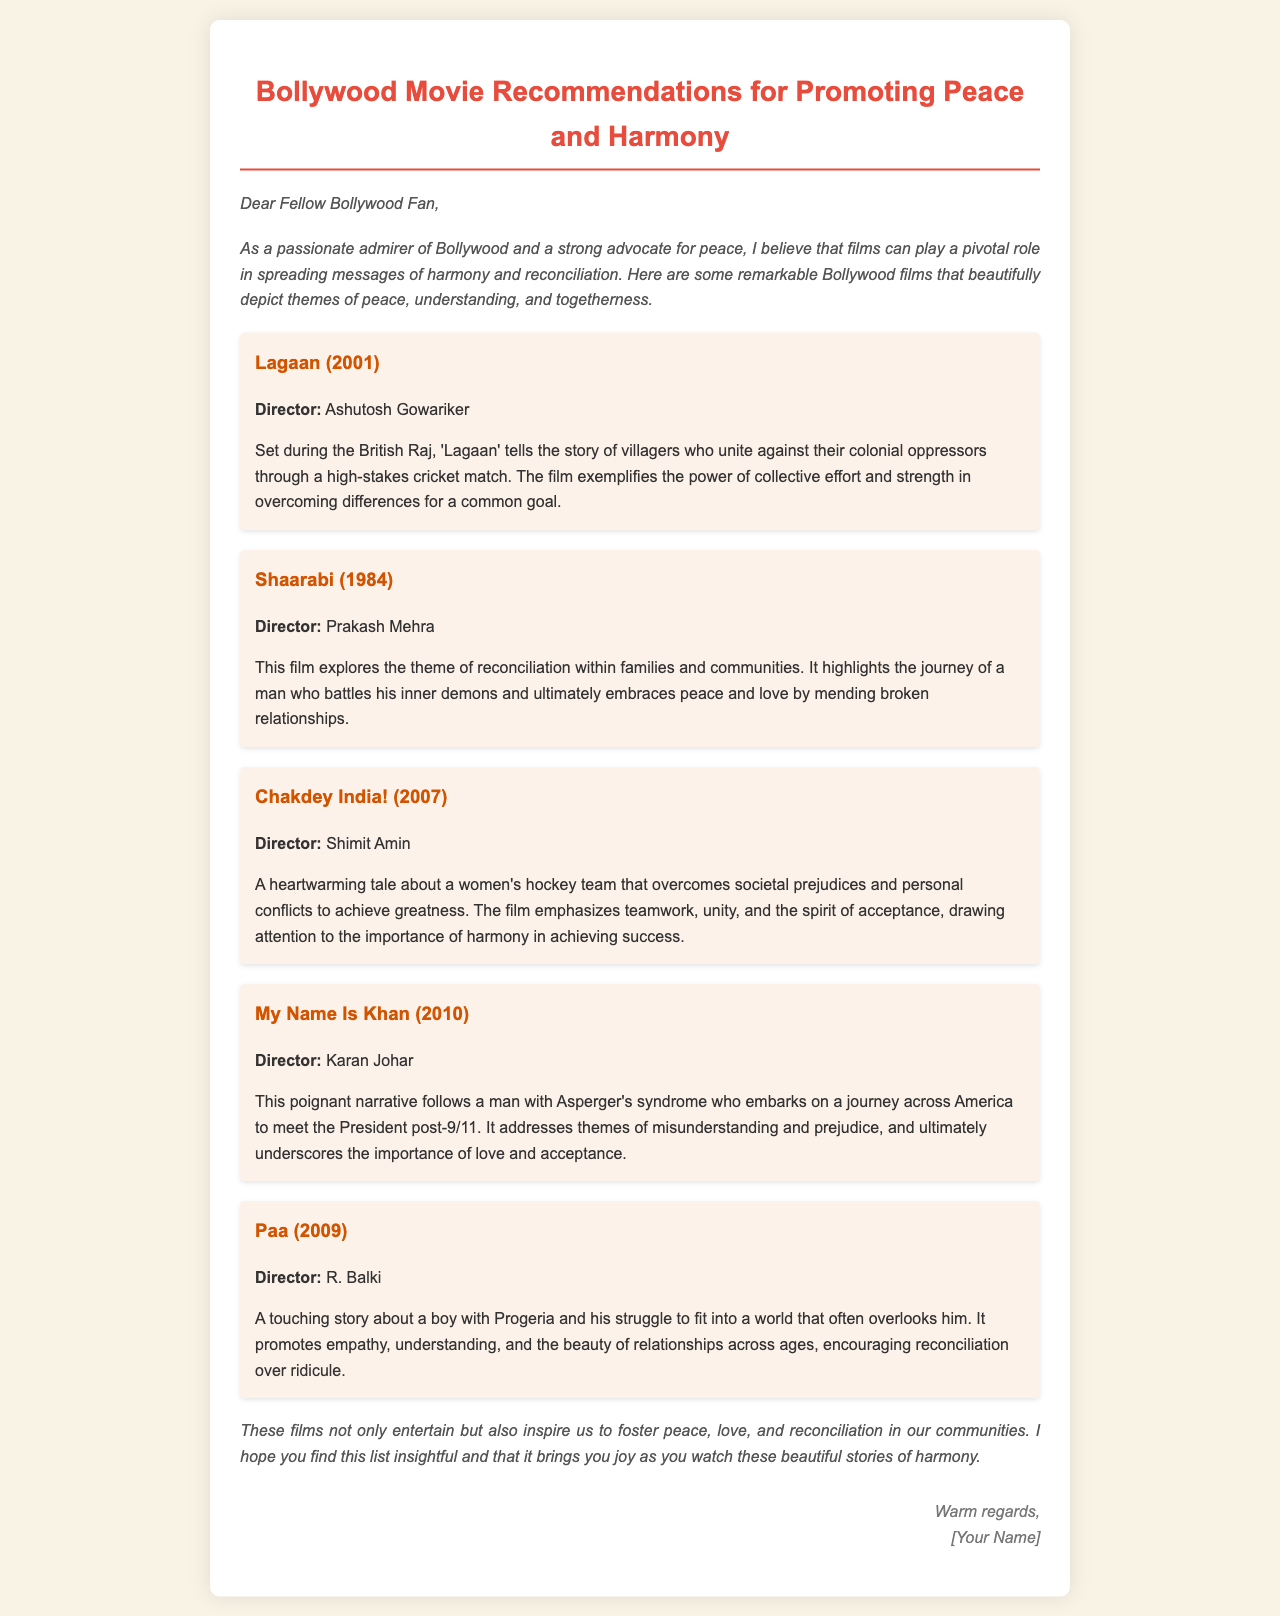What is the title of the email? The title of the email is the first heading presented, which introduces the topic of the email.
Answer: Bollywood Movie Recommendations for Promoting Peace and Harmony Who directed Lagaan? The document specifies the director of Lagaan in the overview of the film.
Answer: Ashutosh Gowariker What year was My Name Is Khan released? The document includes the year each film was released in its description.
Answer: 2010 What central theme does Chakdey India! address? The theme is summarized in the description provided for the film in the document.
Answer: Teamwork and unity Which film portrays a character with Progeria? The document identifies the film dealing with a character's struggle and the related condition.
Answer: Paa What is the primary focus of Shaarabi? The document highlights the main theme of the film in its overview.
Answer: Reconciliation within families and communities How many movies are recommended in the document? The document lists and describes each recommended film, allowing for a direct count.
Answer: Five What is the tone of the introduction? The tone is summarized in the stylistic elements of the introduction section of the email.
Answer: Passionate and advocacy for peace 